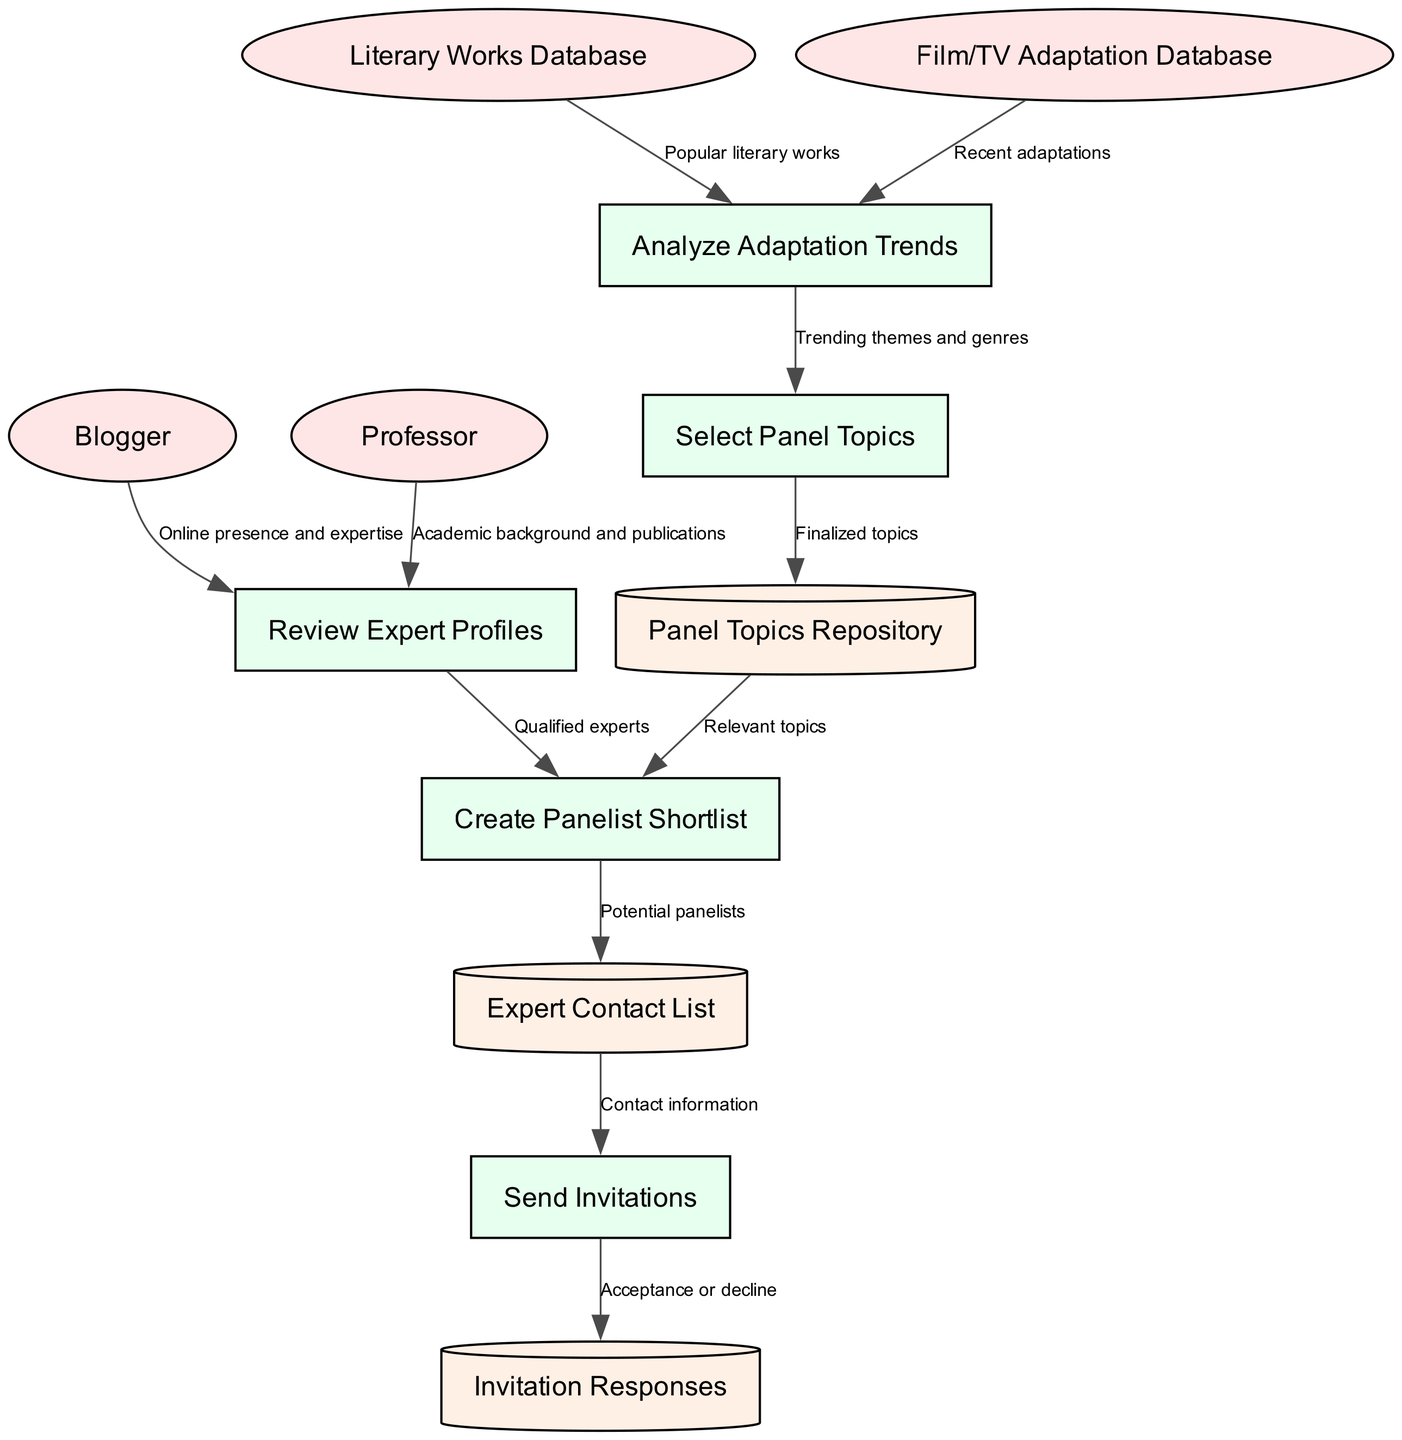What are the external entities in the diagram? The external entities are listed at the beginning of the diagram. They include the Blogger, Professor, Literary Works Database, and Film/TV Adaptation Database.
Answer: Blogger, Professor, Literary Works Database, Film/TV Adaptation Database How many processes are represented in the diagram? The processes section contains five items: Review Expert Profiles, Analyze Adaptation Trends, Select Panel Topics, Create Panelist Shortlist, and Send Invitations. Counting these gives us a total of five processes.
Answer: 5 What data store is used for panel topics? The diagram indicates that topics are stored in the "Panel Topics Repository". This is explicitly labeled in the data store section, indicating its purpose in the flow.
Answer: Panel Topics Repository Which external entity provides popular literary works? The external entity providing popular literary works is the "Literary Works Database". This is indicated as a data source feeding into the Analyze Adaptation Trends process.
Answer: Literary Works Database What is the flow direction from "Create Panelist Shortlist" to "Expert Contact List"? The flow direction shows that after the "Create Panelist Shortlist" process, it provides "Potential panelists" to the "Expert Contact List". This indicates how the shortlisted panelists are categorized.
Answer: Potential panelists Which process leads to the "Select Panel Topics" step? The "Analyze Adaptation Trends" process leads to the "Select Panel Topics" step. This flow shows how analysis of trends informs topic selection.
Answer: Analyze Adaptation Trends What do the invitation responses indicate? The invitation responses capture the "Acceptance or decline" from the "Send Invitations" process. This shows the outcome of the invitation sent to the panelists.
Answer: Acceptance or decline What is the label for the flow from "Select Panel Topics" to "Panel Topics Repository"? The flow from "Select Panel Topics" to "Panel Topics Repository" is labeled "Finalized topics". This indicates that the topics chosen are finalized before being stored.
Answer: Finalized topics Which process does the "Professor" contribute to in the diagram? The "Professor" contributes to the "Review Expert Profiles" process by providing their academic background and publications, as shown in the flow.
Answer: Review Expert Profiles 